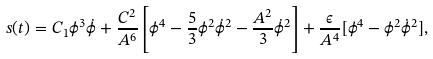<formula> <loc_0><loc_0><loc_500><loc_500>s ( t ) = C _ { 1 } \phi ^ { 3 } \dot { \phi } + \frac { C ^ { 2 } } { A ^ { 6 } } \left [ { \phi ^ { 4 } - \frac { 5 } { 3 } \phi ^ { 2 } \dot { \phi } ^ { 2 } - \frac { A ^ { 2 } } { 3 } \dot { \phi } ^ { 2 } } \right ] + \frac { \epsilon } { A ^ { 4 } } [ \phi ^ { 4 } - \phi ^ { 2 } \dot { \phi } ^ { 2 } ] ,</formula> 